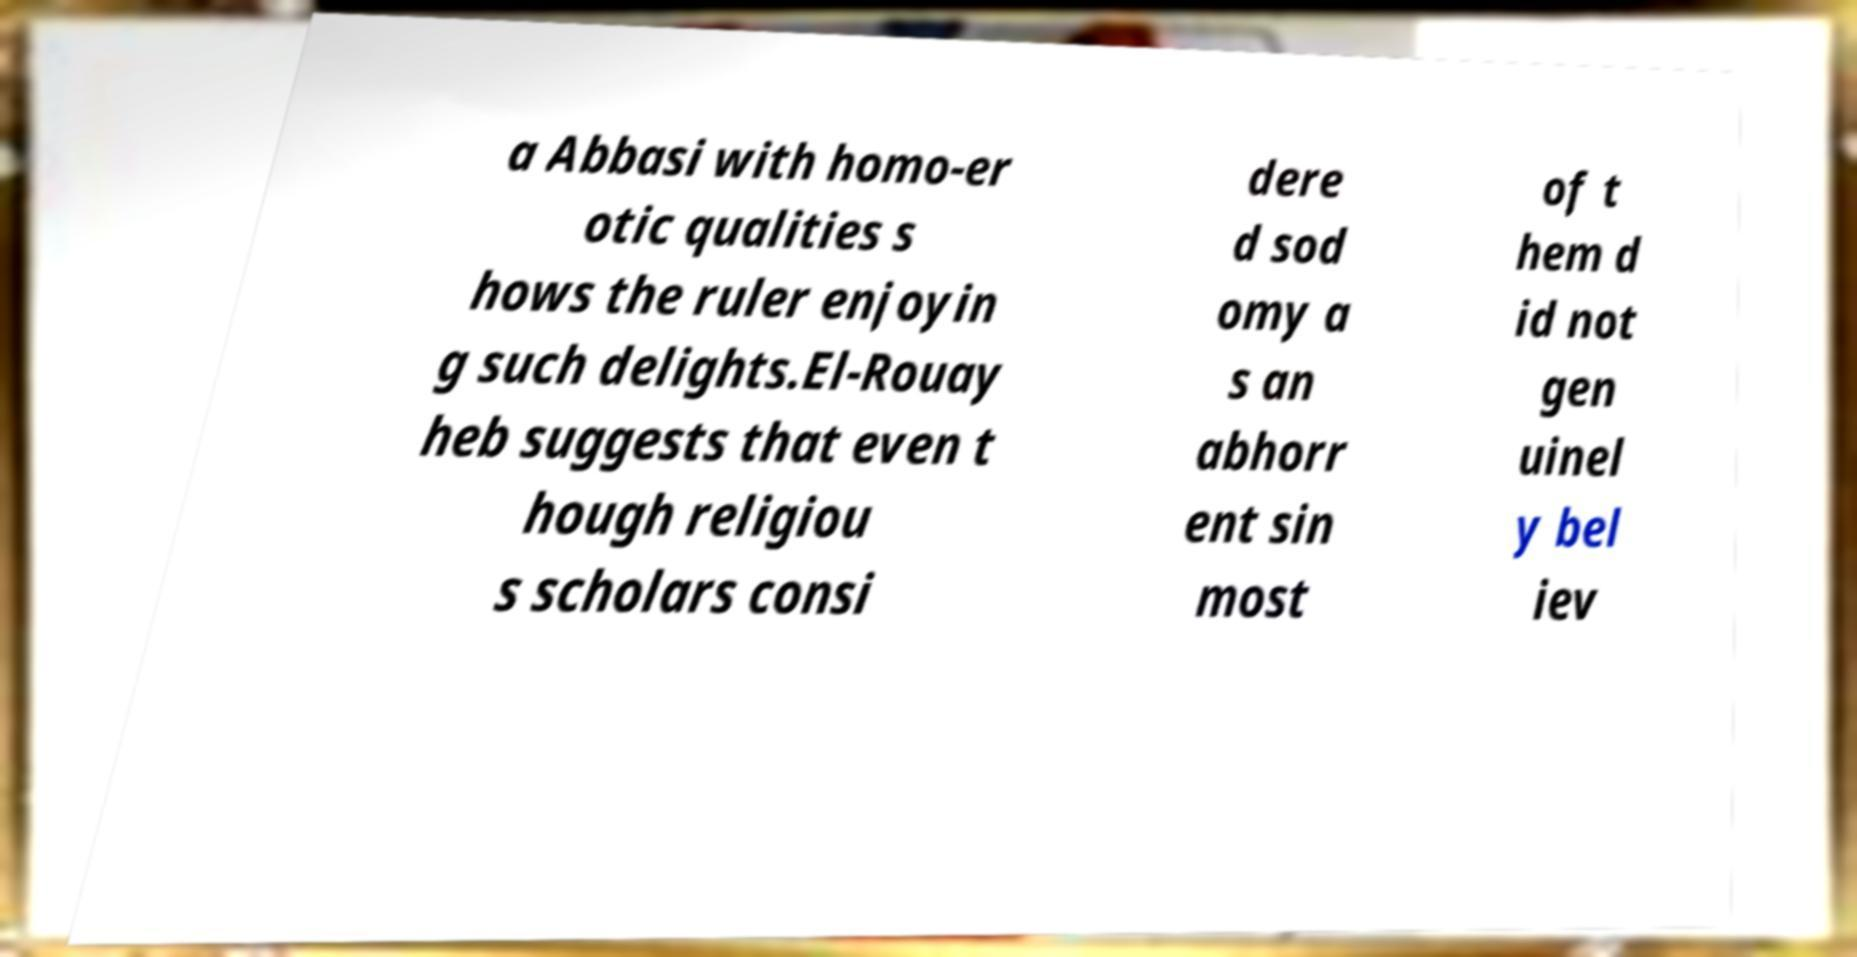Can you accurately transcribe the text from the provided image for me? a Abbasi with homo-er otic qualities s hows the ruler enjoyin g such delights.El-Rouay heb suggests that even t hough religiou s scholars consi dere d sod omy a s an abhorr ent sin most of t hem d id not gen uinel y bel iev 